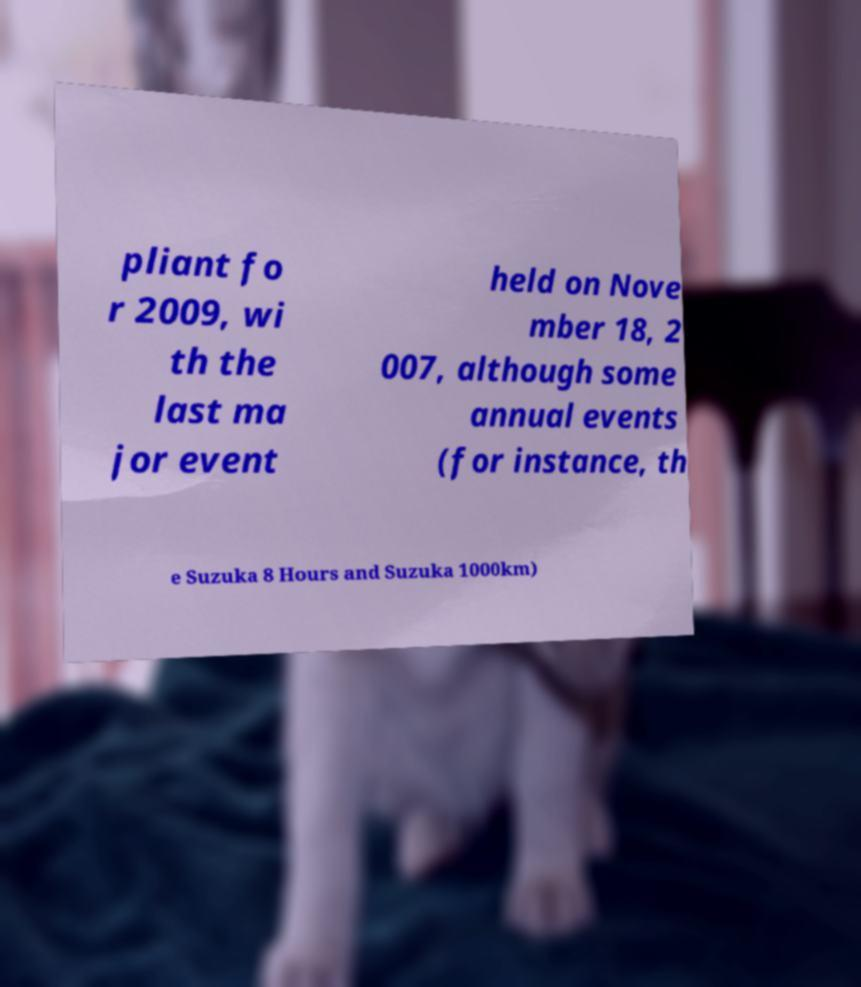There's text embedded in this image that I need extracted. Can you transcribe it verbatim? pliant fo r 2009, wi th the last ma jor event held on Nove mber 18, 2 007, although some annual events (for instance, th e Suzuka 8 Hours and Suzuka 1000km) 